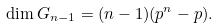Convert formula to latex. <formula><loc_0><loc_0><loc_500><loc_500>\dim G _ { n - 1 } = ( n - 1 ) ( p ^ { n } - p ) .</formula> 